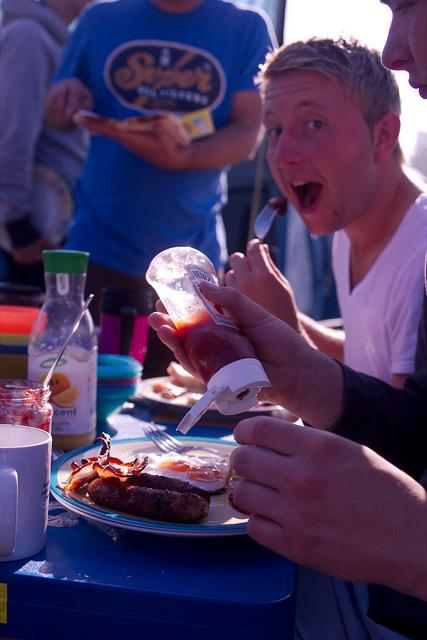Why are the men seated? eating 